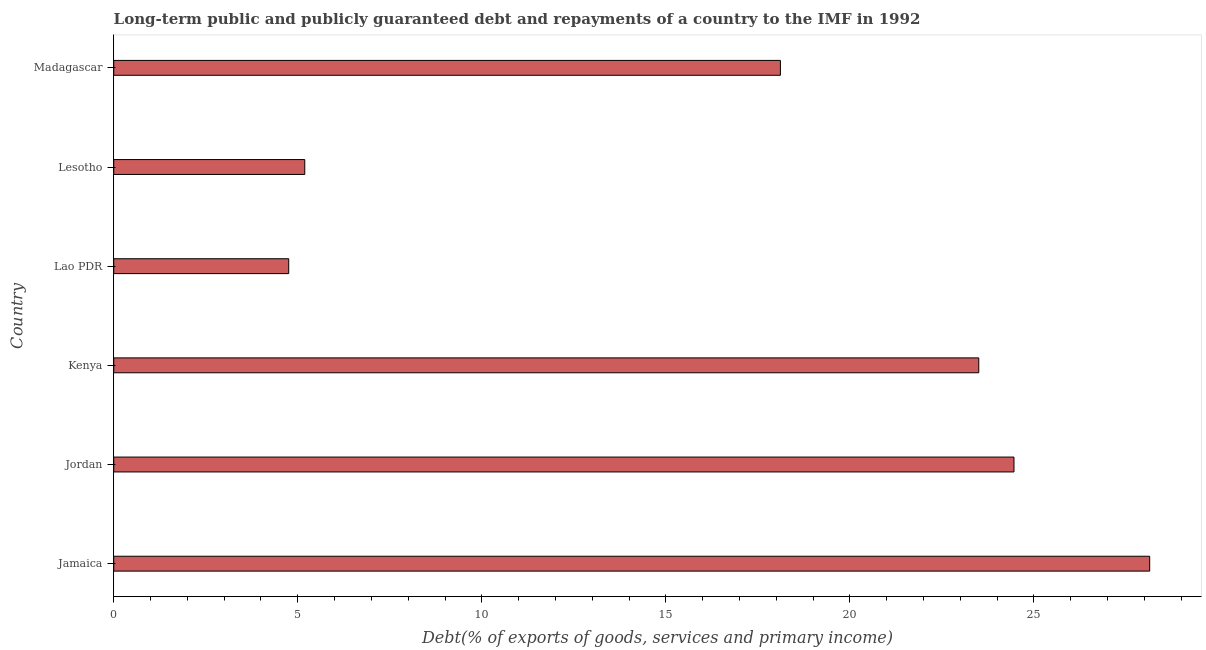What is the title of the graph?
Make the answer very short. Long-term public and publicly guaranteed debt and repayments of a country to the IMF in 1992. What is the label or title of the X-axis?
Provide a short and direct response. Debt(% of exports of goods, services and primary income). What is the debt service in Kenya?
Give a very brief answer. 23.5. Across all countries, what is the maximum debt service?
Provide a succinct answer. 28.14. Across all countries, what is the minimum debt service?
Provide a succinct answer. 4.75. In which country was the debt service maximum?
Offer a terse response. Jamaica. In which country was the debt service minimum?
Make the answer very short. Lao PDR. What is the sum of the debt service?
Your answer should be compact. 104.15. What is the difference between the debt service in Jordan and Lao PDR?
Offer a terse response. 19.7. What is the average debt service per country?
Give a very brief answer. 17.36. What is the median debt service?
Provide a short and direct response. 20.81. What is the ratio of the debt service in Kenya to that in Lao PDR?
Give a very brief answer. 4.94. What is the difference between the highest and the second highest debt service?
Ensure brevity in your answer.  3.69. What is the difference between the highest and the lowest debt service?
Your answer should be very brief. 23.39. How many bars are there?
Your answer should be very brief. 6. How many countries are there in the graph?
Make the answer very short. 6. What is the difference between two consecutive major ticks on the X-axis?
Give a very brief answer. 5. What is the Debt(% of exports of goods, services and primary income) in Jamaica?
Provide a succinct answer. 28.14. What is the Debt(% of exports of goods, services and primary income) of Jordan?
Give a very brief answer. 24.46. What is the Debt(% of exports of goods, services and primary income) in Kenya?
Keep it short and to the point. 23.5. What is the Debt(% of exports of goods, services and primary income) of Lao PDR?
Keep it short and to the point. 4.75. What is the Debt(% of exports of goods, services and primary income) in Lesotho?
Offer a terse response. 5.19. What is the Debt(% of exports of goods, services and primary income) of Madagascar?
Give a very brief answer. 18.11. What is the difference between the Debt(% of exports of goods, services and primary income) in Jamaica and Jordan?
Give a very brief answer. 3.69. What is the difference between the Debt(% of exports of goods, services and primary income) in Jamaica and Kenya?
Ensure brevity in your answer.  4.64. What is the difference between the Debt(% of exports of goods, services and primary income) in Jamaica and Lao PDR?
Your answer should be compact. 23.39. What is the difference between the Debt(% of exports of goods, services and primary income) in Jamaica and Lesotho?
Provide a succinct answer. 22.95. What is the difference between the Debt(% of exports of goods, services and primary income) in Jamaica and Madagascar?
Offer a very short reply. 10.03. What is the difference between the Debt(% of exports of goods, services and primary income) in Jordan and Kenya?
Give a very brief answer. 0.96. What is the difference between the Debt(% of exports of goods, services and primary income) in Jordan and Lao PDR?
Provide a succinct answer. 19.7. What is the difference between the Debt(% of exports of goods, services and primary income) in Jordan and Lesotho?
Your answer should be very brief. 19.27. What is the difference between the Debt(% of exports of goods, services and primary income) in Jordan and Madagascar?
Provide a short and direct response. 6.35. What is the difference between the Debt(% of exports of goods, services and primary income) in Kenya and Lao PDR?
Your answer should be compact. 18.75. What is the difference between the Debt(% of exports of goods, services and primary income) in Kenya and Lesotho?
Provide a succinct answer. 18.31. What is the difference between the Debt(% of exports of goods, services and primary income) in Kenya and Madagascar?
Your answer should be very brief. 5.39. What is the difference between the Debt(% of exports of goods, services and primary income) in Lao PDR and Lesotho?
Provide a succinct answer. -0.44. What is the difference between the Debt(% of exports of goods, services and primary income) in Lao PDR and Madagascar?
Give a very brief answer. -13.36. What is the difference between the Debt(% of exports of goods, services and primary income) in Lesotho and Madagascar?
Offer a very short reply. -12.92. What is the ratio of the Debt(% of exports of goods, services and primary income) in Jamaica to that in Jordan?
Keep it short and to the point. 1.15. What is the ratio of the Debt(% of exports of goods, services and primary income) in Jamaica to that in Kenya?
Make the answer very short. 1.2. What is the ratio of the Debt(% of exports of goods, services and primary income) in Jamaica to that in Lao PDR?
Your answer should be very brief. 5.92. What is the ratio of the Debt(% of exports of goods, services and primary income) in Jamaica to that in Lesotho?
Provide a succinct answer. 5.42. What is the ratio of the Debt(% of exports of goods, services and primary income) in Jamaica to that in Madagascar?
Your answer should be very brief. 1.55. What is the ratio of the Debt(% of exports of goods, services and primary income) in Jordan to that in Kenya?
Keep it short and to the point. 1.04. What is the ratio of the Debt(% of exports of goods, services and primary income) in Jordan to that in Lao PDR?
Ensure brevity in your answer.  5.14. What is the ratio of the Debt(% of exports of goods, services and primary income) in Jordan to that in Lesotho?
Provide a short and direct response. 4.71. What is the ratio of the Debt(% of exports of goods, services and primary income) in Jordan to that in Madagascar?
Make the answer very short. 1.35. What is the ratio of the Debt(% of exports of goods, services and primary income) in Kenya to that in Lao PDR?
Offer a terse response. 4.94. What is the ratio of the Debt(% of exports of goods, services and primary income) in Kenya to that in Lesotho?
Make the answer very short. 4.53. What is the ratio of the Debt(% of exports of goods, services and primary income) in Kenya to that in Madagascar?
Provide a succinct answer. 1.3. What is the ratio of the Debt(% of exports of goods, services and primary income) in Lao PDR to that in Lesotho?
Your response must be concise. 0.92. What is the ratio of the Debt(% of exports of goods, services and primary income) in Lao PDR to that in Madagascar?
Your response must be concise. 0.26. What is the ratio of the Debt(% of exports of goods, services and primary income) in Lesotho to that in Madagascar?
Offer a terse response. 0.29. 